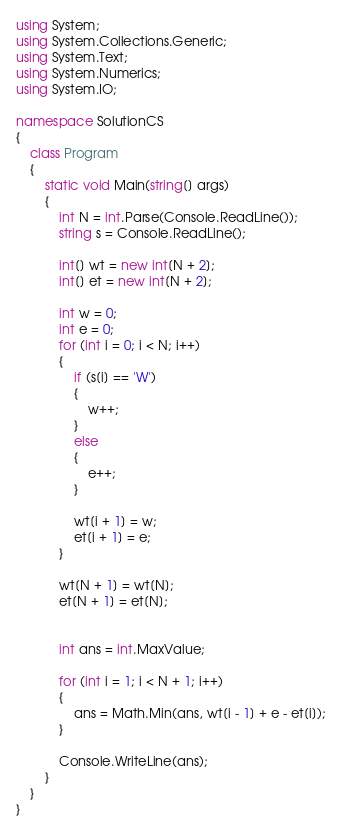<code> <loc_0><loc_0><loc_500><loc_500><_C#_>using System;
using System.Collections.Generic;
using System.Text;
using System.Numerics;
using System.IO;

namespace SolutionCS
{
    class Program
    {
        static void Main(string[] args)
        {
            int N = int.Parse(Console.ReadLine());
            string s = Console.ReadLine();

            int[] wt = new int[N + 2];
            int[] et = new int[N + 2];

            int w = 0;
            int e = 0;
            for (int i = 0; i < N; i++)
            {
                if (s[i] == 'W')
                {
                    w++;
                }
                else
                {
                    e++;
                }

                wt[i + 1] = w;
                et[i + 1] = e;
            }

            wt[N + 1] = wt[N];
            et[N + 1] = et[N];


            int ans = int.MaxValue;

            for (int i = 1; i < N + 1; i++)
            {
                ans = Math.Min(ans, wt[i - 1] + e - et[i]);
            }

            Console.WriteLine(ans);
        }
    }
}

</code> 